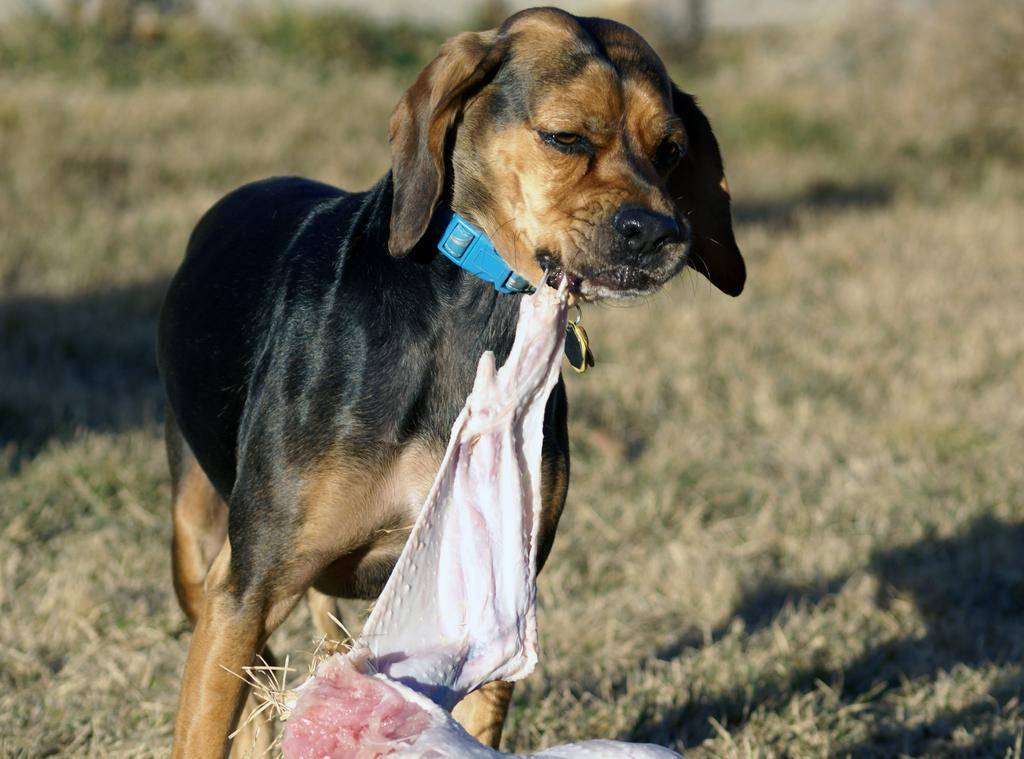What type of animal is in the image? There is a dog in the image. What is the dog doing in the image? The dog is standing and holding meat in its mouth. What is around the dog's neck? The dog has a belt around its neck. What can be seen in the background of the image? There is grass and shadows visible in the background of the image. How many nuts are the dog answering in the image? There are no nuts present in the image, nor is the dog answering any questions. 